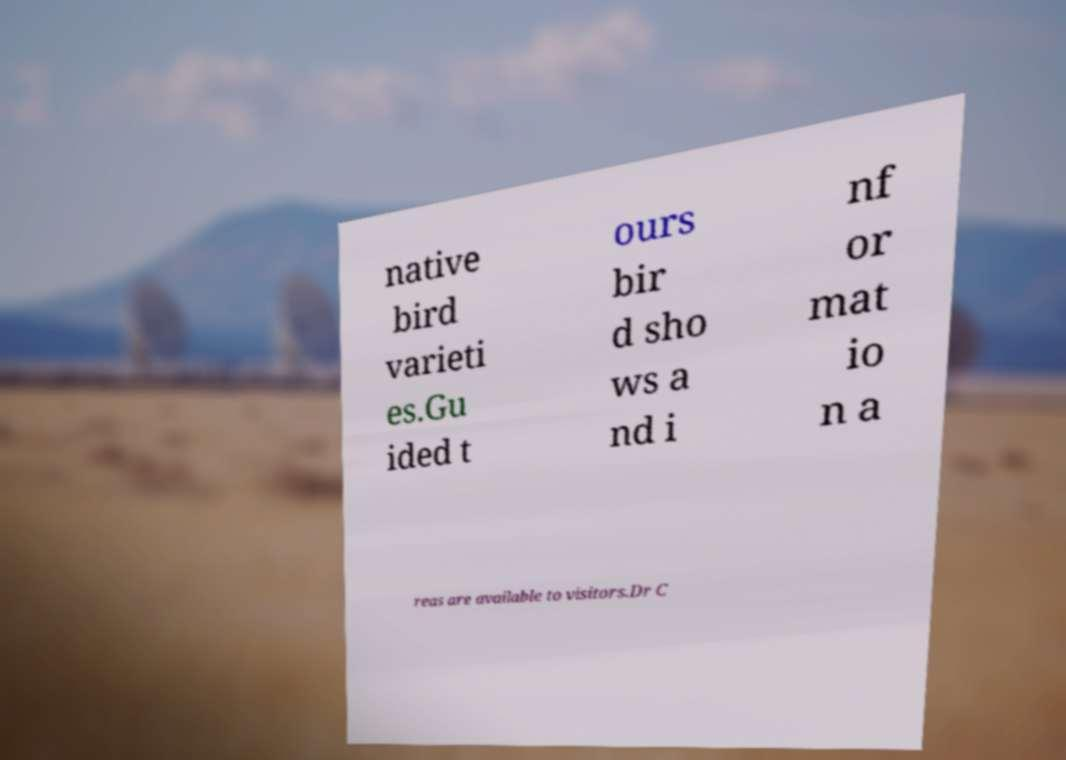What messages or text are displayed in this image? I need them in a readable, typed format. native bird varieti es.Gu ided t ours bir d sho ws a nd i nf or mat io n a reas are available to visitors.Dr C 